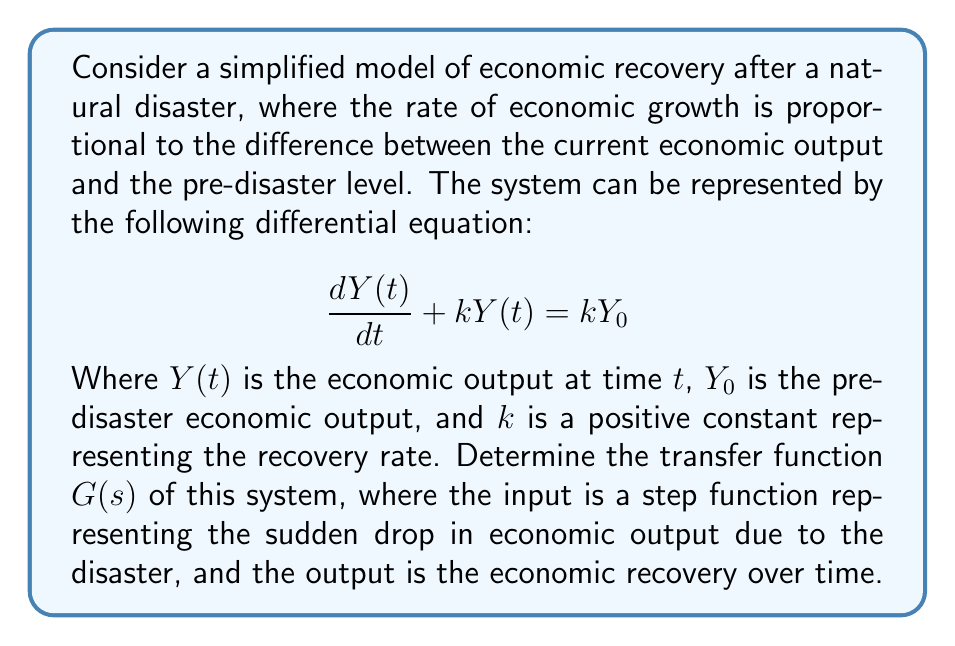Can you solve this math problem? To determine the transfer function of this system, we'll follow these steps:

1) First, let's take the Laplace transform of both sides of the differential equation:

   $$\mathcal{L}\left\{\frac{dY(t)}{dt} + kY(t)\right\} = \mathcal{L}\{kY_0\}$$

2) Using the properties of the Laplace transform:

   $$sY(s) - Y(0) + kY(s) = \frac{kY_0}{s}$$

   Where $Y(s)$ is the Laplace transform of $Y(t)$, and $Y(0)$ is the initial condition (economic output immediately after the disaster).

3) Rearrange the equation:

   $$(s + k)Y(s) - Y(0) = \frac{kY_0}{s}$$

4) Solve for $Y(s)$:

   $$Y(s) = \frac{Y(0)}{s + k} + \frac{kY_0}{s(s + k)}$$

5) The transfer function $G(s)$ is defined as the ratio of the output $Y(s)$ to the input, which in this case is a step function. The Laplace transform of a step function with magnitude $(Y_0 - Y(0))$ is $\frac{Y_0 - Y(0)}{s}$.

6) Therefore, the transfer function is:

   $$G(s) = \frac{Y(s)}{\frac{Y_0 - Y(0)}{s}} = \frac{sY(0) + kY_0}{(s + k)(Y_0 - Y(0))}$$

7) Simplify:

   $$G(s) = \frac{k}{s + k} + \frac{sY(0)}{(s + k)(Y_0 - Y(0))}$$

This transfer function represents how the economic system responds to the sudden shock of a natural disaster and recovers over time.
Answer: $$G(s) = \frac{k}{s + k} + \frac{sY(0)}{(s + k)(Y_0 - Y(0))}$$ 